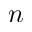Convert formula to latex. <formula><loc_0><loc_0><loc_500><loc_500>n</formula> 